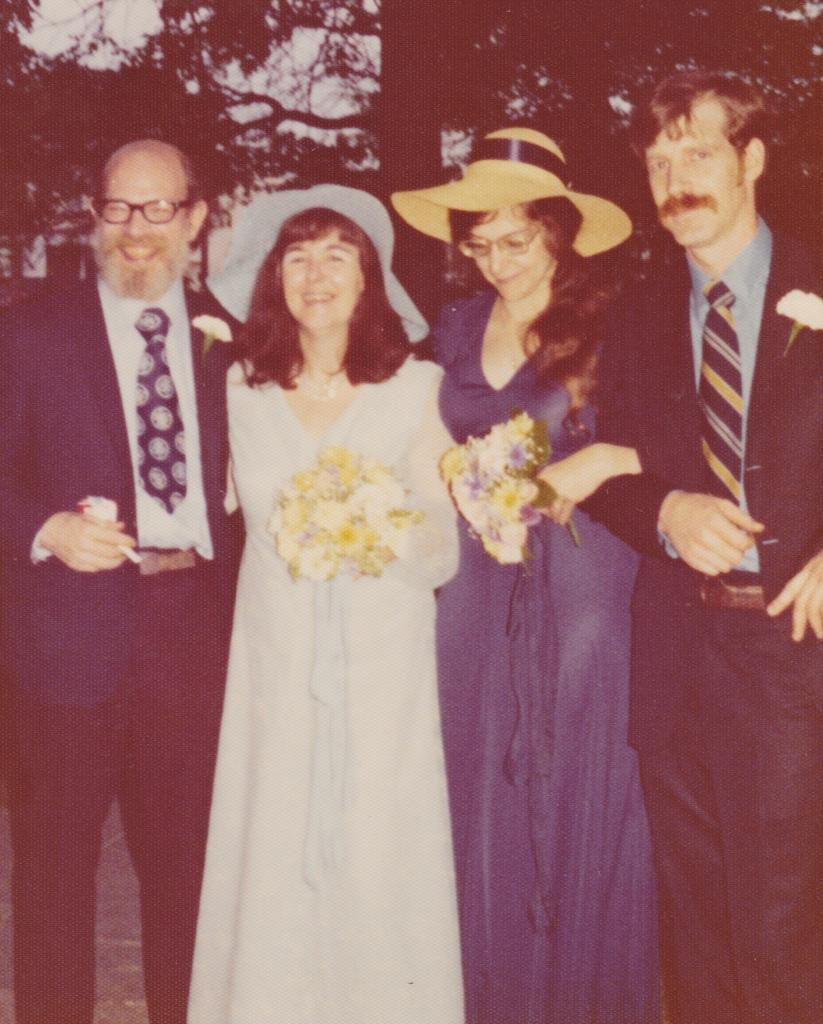How many people are in the image? There is a group of persons in the image. What are the persons in the image doing? The persons are standing and smiling. What are the persons holding in their hands? The persons are holding flowers in their hands. What can be seen in the background of the image? There are trees visible in the background of the image. What type of room can be seen in the image? There is no room visible in the image; it is an outdoor scene with trees in the background. What is the current temperature in the image? The provided facts do not give any information about the temperature in the image. 